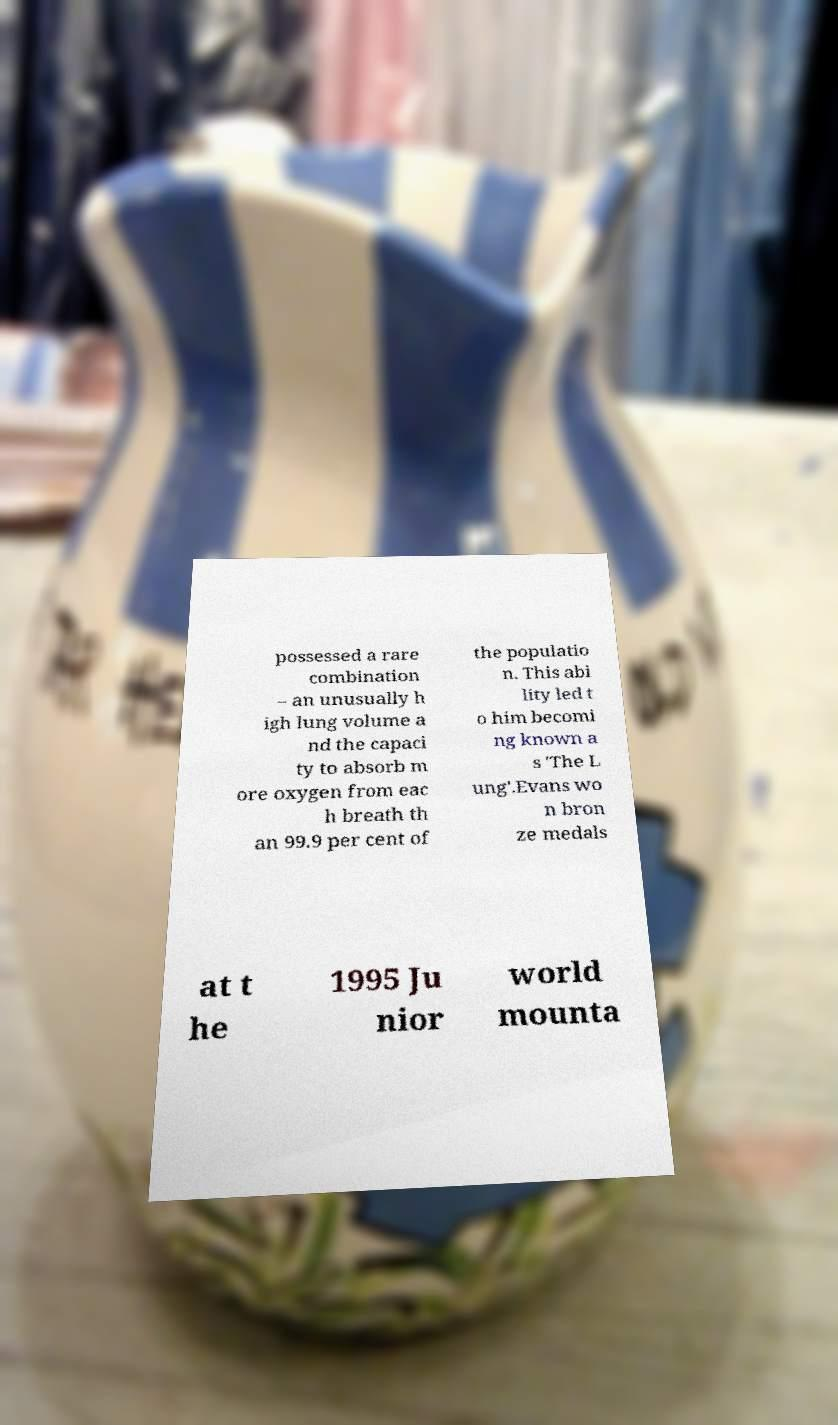I need the written content from this picture converted into text. Can you do that? possessed a rare combination – an unusually h igh lung volume a nd the capaci ty to absorb m ore oxygen from eac h breath th an 99.9 per cent of the populatio n. This abi lity led t o him becomi ng known a s 'The L ung'.Evans wo n bron ze medals at t he 1995 Ju nior world mounta 